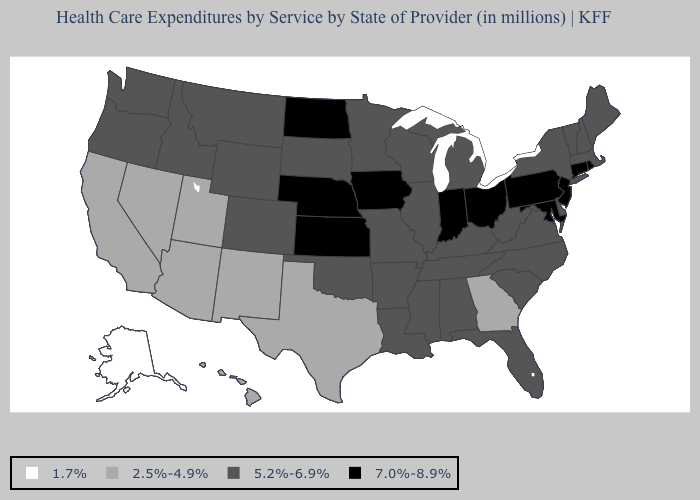Name the states that have a value in the range 5.2%-6.9%?
Short answer required. Alabama, Arkansas, Colorado, Delaware, Florida, Idaho, Illinois, Kentucky, Louisiana, Maine, Massachusetts, Michigan, Minnesota, Mississippi, Missouri, Montana, New Hampshire, New York, North Carolina, Oklahoma, Oregon, South Carolina, South Dakota, Tennessee, Vermont, Virginia, Washington, West Virginia, Wisconsin, Wyoming. What is the highest value in states that border Nebraska?
Be succinct. 7.0%-8.9%. Which states have the highest value in the USA?
Quick response, please. Connecticut, Indiana, Iowa, Kansas, Maryland, Nebraska, New Jersey, North Dakota, Ohio, Pennsylvania, Rhode Island. What is the value of Virginia?
Answer briefly. 5.2%-6.9%. Does Oregon have the same value as Iowa?
Keep it brief. No. What is the highest value in states that border Massachusetts?
Answer briefly. 7.0%-8.9%. How many symbols are there in the legend?
Concise answer only. 4. What is the highest value in states that border Washington?
Short answer required. 5.2%-6.9%. Does the first symbol in the legend represent the smallest category?
Answer briefly. Yes. Does Ohio have the lowest value in the MidWest?
Answer briefly. No. Does Alaska have the lowest value in the USA?
Be succinct. Yes. Name the states that have a value in the range 2.5%-4.9%?
Short answer required. Arizona, California, Georgia, Hawaii, Nevada, New Mexico, Texas, Utah. What is the value of Missouri?
Write a very short answer. 5.2%-6.9%. What is the highest value in the USA?
Give a very brief answer. 7.0%-8.9%. Does New York have the lowest value in the Northeast?
Answer briefly. Yes. 